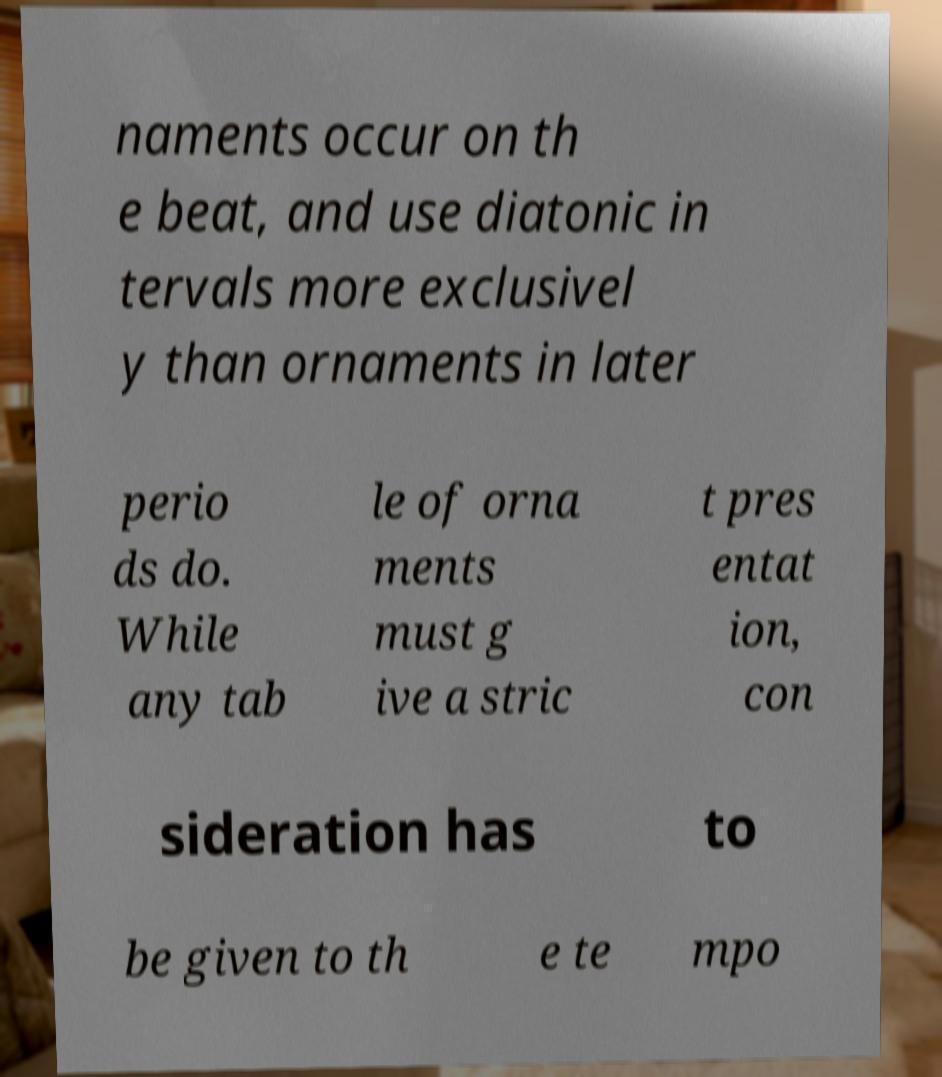Could you extract and type out the text from this image? naments occur on th e beat, and use diatonic in tervals more exclusivel y than ornaments in later perio ds do. While any tab le of orna ments must g ive a stric t pres entat ion, con sideration has to be given to th e te mpo 